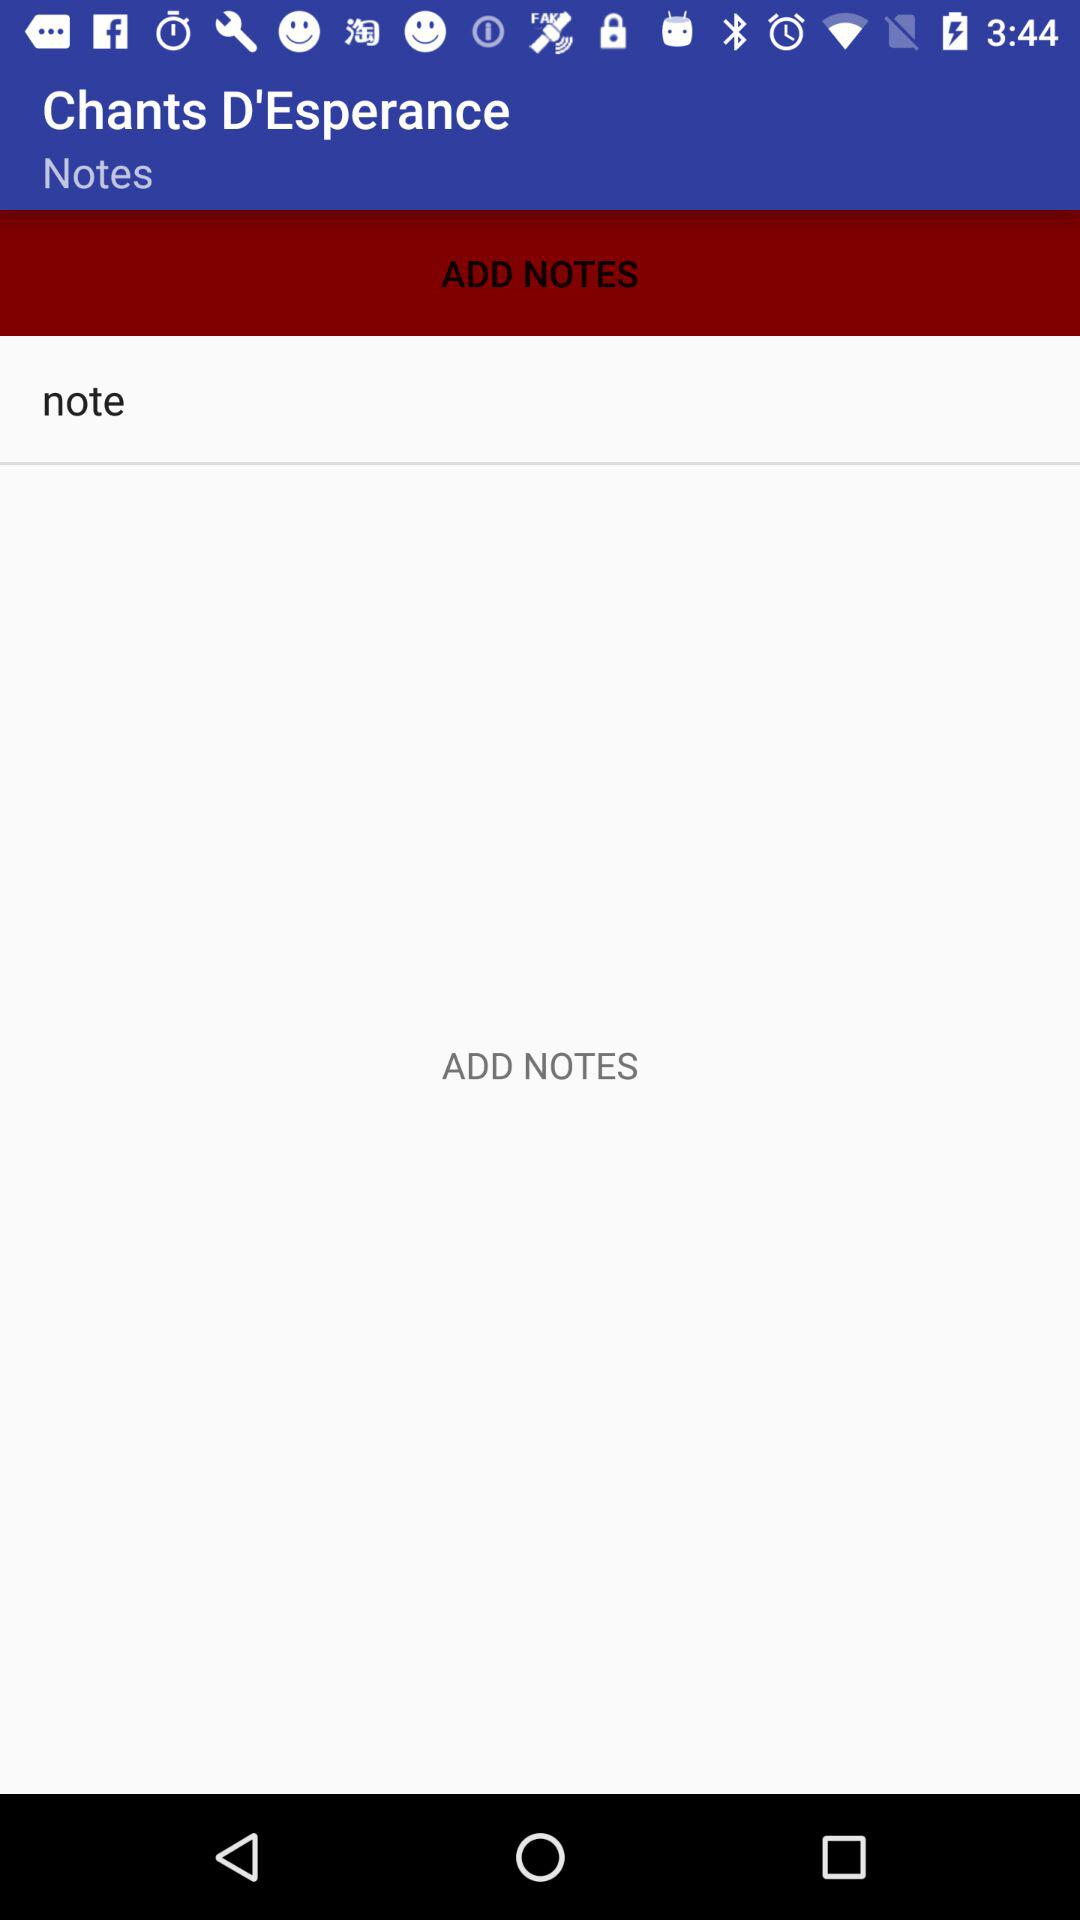What is the application name? The application name is "Chants D'Esperance". 